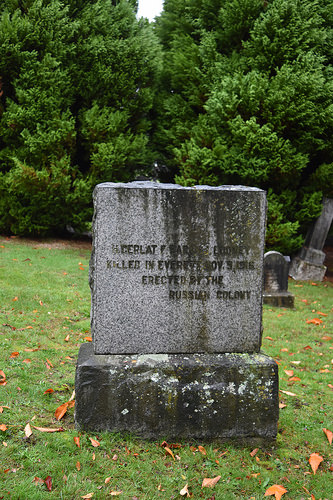<image>
Can you confirm if the tombstone is to the left of the tombstone? Yes. From this viewpoint, the tombstone is positioned to the left side relative to the tombstone. 